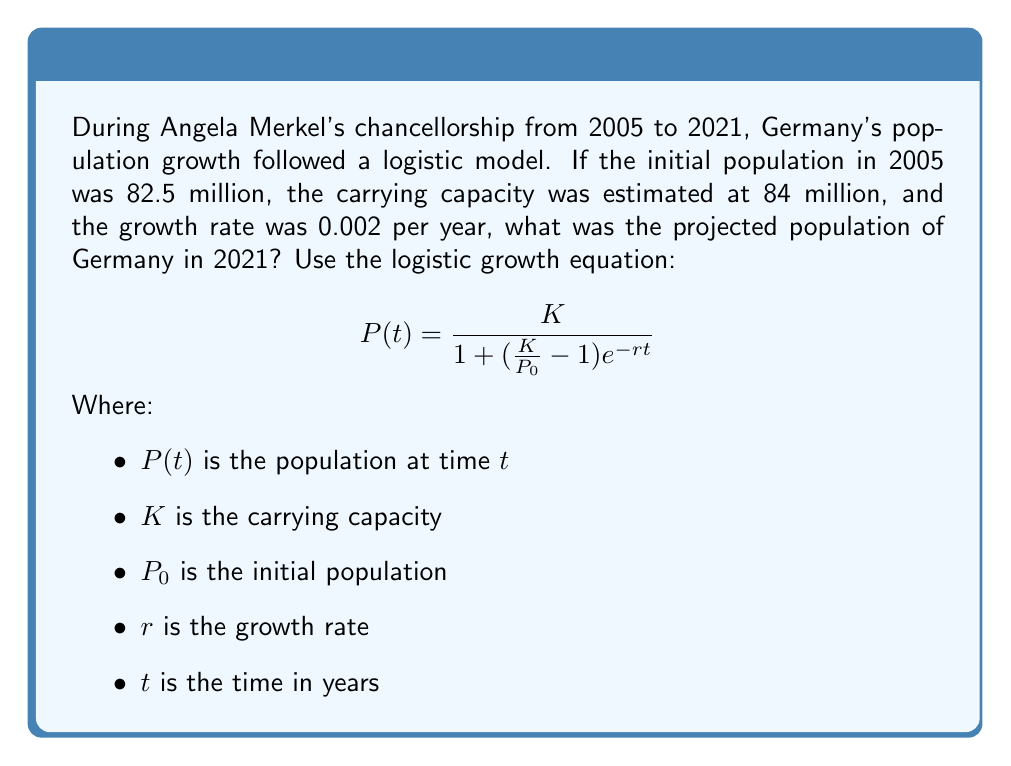Help me with this question. To solve this problem, we'll use the logistic growth equation and plug in the given values:

$K = 84$ million (carrying capacity)
$P_0 = 82.5$ million (initial population in 2005)
$r = 0.002$ per year (growth rate)
$t = 16$ years (from 2005 to 2021)

Let's substitute these values into the equation:

$$P(16) = \frac{84}{1 + (\frac{84}{82.5} - 1)e^{-0.002 \times 16}}$$

Now, let's solve this step by step:

1. Calculate $\frac{K}{P_0}$:
   $\frac{84}{82.5} = 1.0181818$

2. Subtract 1 from this value:
   $1.0181818 - 1 = 0.0181818$

3. Calculate $e^{-rt}$:
   $e^{-0.002 \times 16} = e^{-0.032} = 0.9685074$

4. Multiply the results from steps 2 and 3:
   $0.0181818 \times 0.9685074 = 0.0176091$

5. Add 1 to this result:
   $1 + 0.0176091 = 1.0176091$

6. Divide $K$ by this final value:
   $\frac{84}{1.0176091} = 82.5463$

Therefore, the projected population of Germany in 2021 is approximately 82.55 million.
Answer: 82.55 million 